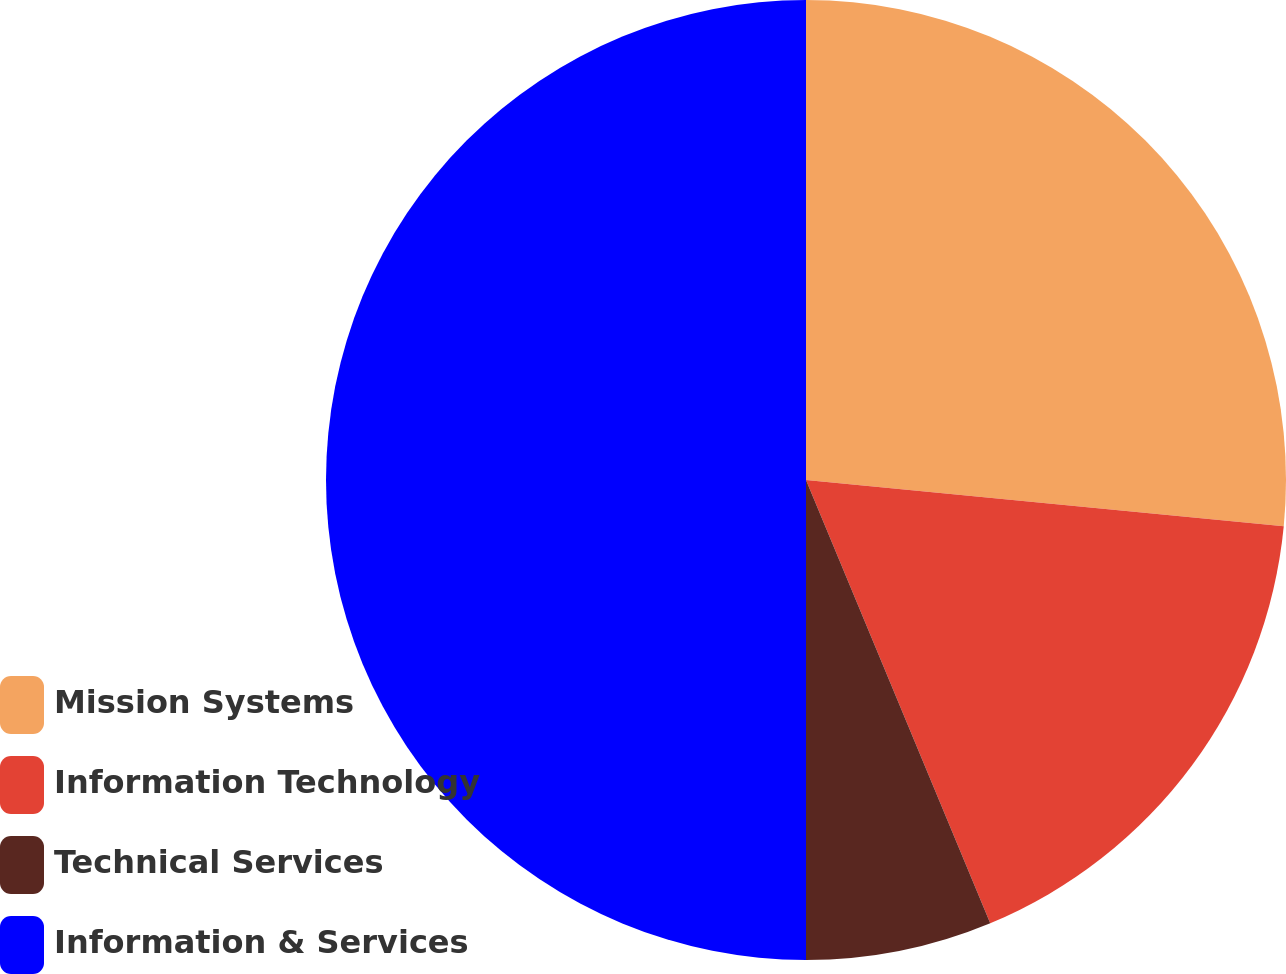Convert chart to OTSL. <chart><loc_0><loc_0><loc_500><loc_500><pie_chart><fcel>Mission Systems<fcel>Information Technology<fcel>Technical Services<fcel>Information & Services<nl><fcel>26.54%<fcel>17.19%<fcel>6.27%<fcel>50.0%<nl></chart> 